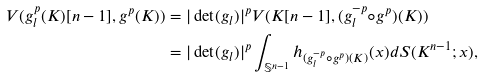Convert formula to latex. <formula><loc_0><loc_0><loc_500><loc_500>V ( g _ { l } ^ { p } ( K ) [ n - 1 ] , g ^ { p } ( K ) ) & = | \det ( g _ { l } ) | ^ { p } V ( K [ n - 1 ] , ( g _ { l } ^ { - p } \circ g ^ { p } ) ( K ) ) \\ & = | \det ( g _ { l } ) | ^ { p } \int _ { \mathbb { S } ^ { n - 1 } } h _ { ( g _ { l } ^ { - p } { \circ } g ^ { p } ) ( K ) } ( x ) d S ( K ^ { n - 1 } ; x ) ,</formula> 